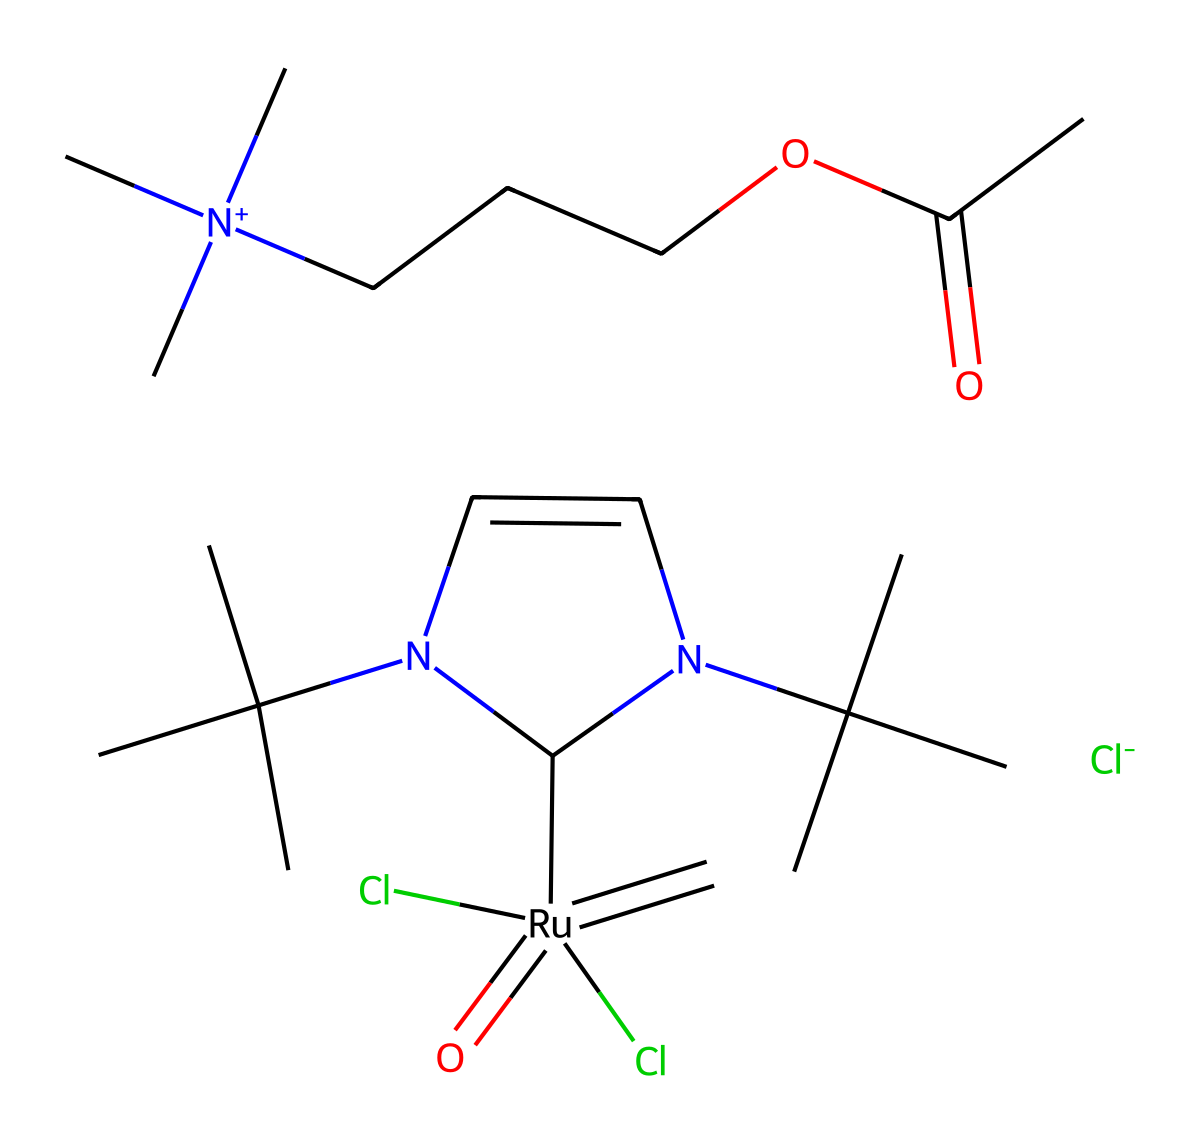What is the central metal in this compound? The central metal can be identified by the notation in the SMILES, particularly the part that shows "[Ru]". This indicates that Ruthenium is the metal at the center of the coordination complex involving carbene ligands.
Answer: Ruthenium How many chlorine atoms are present in the structure? By analyzing the SMILES representation, we observe that there are two "Cl" notations present, indicating there are two chlorine atoms associated with the Ruthenium center.
Answer: 2 How many nitrogen atoms are present in this chemical structure? The chemical structure contains two nitrogen atoms, as indicated by the two "N" notations present in the SMILES. Each nitrogen atom is part of the five-membered ring structure involving the carbene ligands.
Answer: 2 Is this compound likely to be soluble in organic solvents? Considering the presence of various alkyl groups which are hydrophobic, along with the nitrogen and the carboxylic acid which can provide some polarity, we can infer that it may have moderate solubility in organic solvents due to the overall structure.
Answer: Yes What type of ligands is represented in this compound? The presence of the carbene structure, indicated by the "=C" notation attached to the Ru center, signifies that carbene ligands are present. Carbene ligands are characterized by having a divalent carbon atom that is able to coordinate to the metal center.
Answer: Carbene 